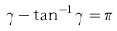<formula> <loc_0><loc_0><loc_500><loc_500>\gamma - \tan ^ { - 1 } \gamma = \pi</formula> 